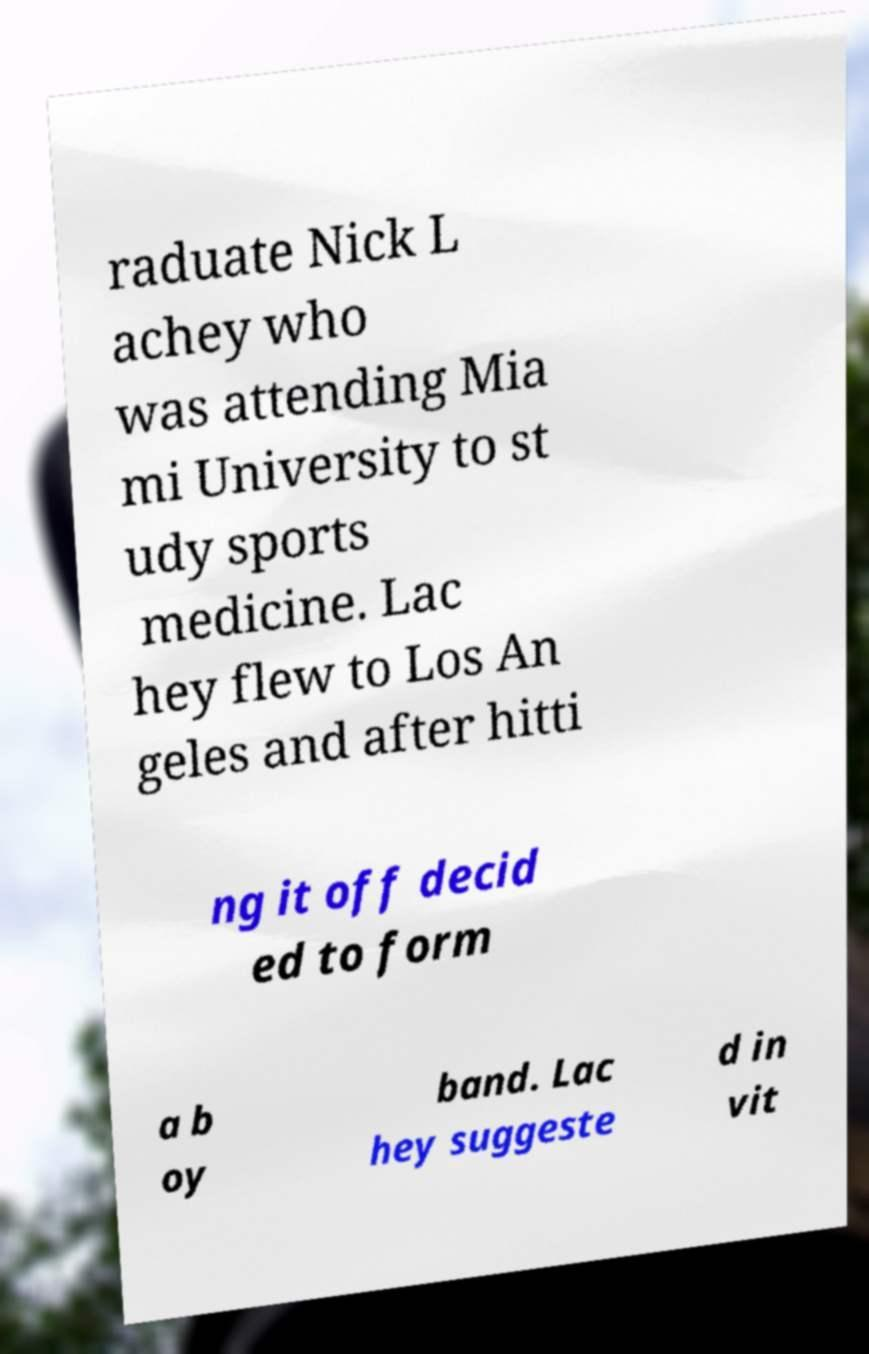I need the written content from this picture converted into text. Can you do that? raduate Nick L achey who was attending Mia mi University to st udy sports medicine. Lac hey flew to Los An geles and after hitti ng it off decid ed to form a b oy band. Lac hey suggeste d in vit 